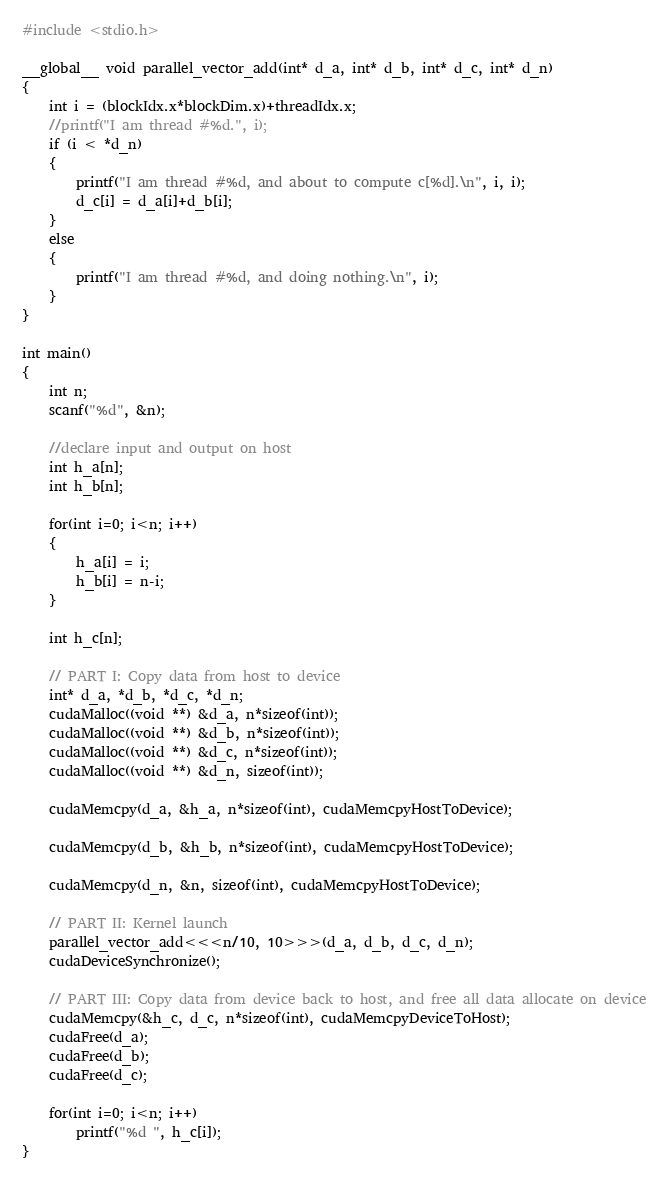<code> <loc_0><loc_0><loc_500><loc_500><_Cuda_>#include <stdio.h>

__global__ void parallel_vector_add(int* d_a, int* d_b, int* d_c, int* d_n)
{
	int i = (blockIdx.x*blockDim.x)+threadIdx.x;
	//printf("I am thread #%d.", i);
	if (i < *d_n)
	{
		printf("I am thread #%d, and about to compute c[%d].\n", i, i);
		d_c[i] = d_a[i]+d_b[i];
	}
	else
	{
		printf("I am thread #%d, and doing nothing.\n", i);
	}
}

int main()
{
	int n;
	scanf("%d", &n);

	//declare input and output on host
	int h_a[n];
	int h_b[n];

	for(int i=0; i<n; i++)
	{
		h_a[i] = i;
		h_b[i] = n-i;
	}

	int h_c[n];

	// PART I: Copy data from host to device
	int* d_a, *d_b, *d_c, *d_n;
	cudaMalloc((void **) &d_a, n*sizeof(int));
	cudaMalloc((void **) &d_b, n*sizeof(int));
	cudaMalloc((void **) &d_c, n*sizeof(int));
	cudaMalloc((void **) &d_n, sizeof(int));

	cudaMemcpy(d_a, &h_a, n*sizeof(int), cudaMemcpyHostToDevice);
	
	cudaMemcpy(d_b, &h_b, n*sizeof(int), cudaMemcpyHostToDevice);
	
	cudaMemcpy(d_n, &n, sizeof(int), cudaMemcpyHostToDevice);

	// PART II: Kernel launch
	parallel_vector_add<<<n/10, 10>>>(d_a, d_b, d_c, d_n);
	cudaDeviceSynchronize();

	// PART III: Copy data from device back to host, and free all data allocate on device
	cudaMemcpy(&h_c, d_c, n*sizeof(int), cudaMemcpyDeviceToHost);
	cudaFree(d_a);
	cudaFree(d_b);
	cudaFree(d_c);

	for(int i=0; i<n; i++)
		printf("%d ", h_c[i]);
}
</code> 